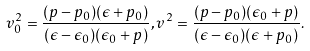<formula> <loc_0><loc_0><loc_500><loc_500>v _ { 0 } ^ { 2 } = \frac { ( p - p _ { 0 } ) ( \epsilon + p _ { 0 } ) } { ( \epsilon - \epsilon _ { 0 } ) ( \epsilon _ { 0 } + p ) } , v ^ { 2 } = \frac { ( p - p _ { 0 } ) ( \epsilon _ { 0 } + p ) } { ( \epsilon - \epsilon _ { 0 } ) ( \epsilon + p _ { 0 } ) } .</formula> 